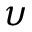Convert formula to latex. <formula><loc_0><loc_0><loc_500><loc_500>\upsilon</formula> 